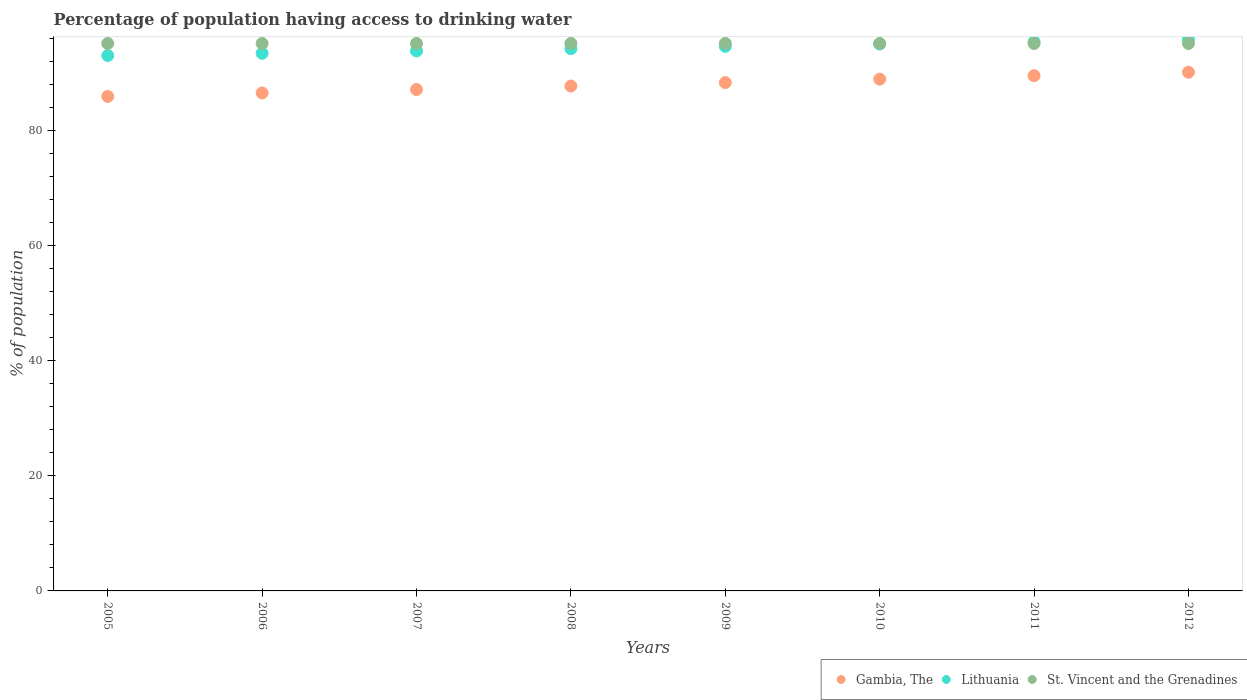Is the number of dotlines equal to the number of legend labels?
Make the answer very short. Yes. What is the percentage of population having access to drinking water in Lithuania in 2006?
Your response must be concise. 93.4. Across all years, what is the maximum percentage of population having access to drinking water in Gambia, The?
Your answer should be compact. 90.1. Across all years, what is the minimum percentage of population having access to drinking water in St. Vincent and the Grenadines?
Your answer should be very brief. 95.1. In which year was the percentage of population having access to drinking water in Gambia, The maximum?
Provide a short and direct response. 2012. What is the total percentage of population having access to drinking water in St. Vincent and the Grenadines in the graph?
Keep it short and to the point. 760.8. What is the difference between the percentage of population having access to drinking water in St. Vincent and the Grenadines in 2010 and that in 2011?
Give a very brief answer. 0. What is the difference between the percentage of population having access to drinking water in Gambia, The in 2012 and the percentage of population having access to drinking water in Lithuania in 2007?
Your answer should be very brief. -3.7. What is the average percentage of population having access to drinking water in Lithuania per year?
Keep it short and to the point. 94.4. In the year 2012, what is the difference between the percentage of population having access to drinking water in Lithuania and percentage of population having access to drinking water in Gambia, The?
Give a very brief answer. 5.7. In how many years, is the percentage of population having access to drinking water in St. Vincent and the Grenadines greater than 44 %?
Keep it short and to the point. 8. What is the ratio of the percentage of population having access to drinking water in Gambia, The in 2007 to that in 2009?
Offer a terse response. 0.99. What is the difference between the highest and the second highest percentage of population having access to drinking water in Lithuania?
Offer a very short reply. 0.4. What is the difference between the highest and the lowest percentage of population having access to drinking water in Lithuania?
Keep it short and to the point. 2.8. Is the percentage of population having access to drinking water in Lithuania strictly greater than the percentage of population having access to drinking water in St. Vincent and the Grenadines over the years?
Your response must be concise. No. Is the percentage of population having access to drinking water in Lithuania strictly less than the percentage of population having access to drinking water in Gambia, The over the years?
Give a very brief answer. No. Are the values on the major ticks of Y-axis written in scientific E-notation?
Make the answer very short. No. Does the graph contain any zero values?
Ensure brevity in your answer.  No. Does the graph contain grids?
Keep it short and to the point. No. How many legend labels are there?
Provide a short and direct response. 3. How are the legend labels stacked?
Ensure brevity in your answer.  Horizontal. What is the title of the graph?
Offer a terse response. Percentage of population having access to drinking water. What is the label or title of the Y-axis?
Provide a succinct answer. % of population. What is the % of population in Gambia, The in 2005?
Keep it short and to the point. 85.9. What is the % of population of Lithuania in 2005?
Your response must be concise. 93. What is the % of population of St. Vincent and the Grenadines in 2005?
Make the answer very short. 95.1. What is the % of population of Gambia, The in 2006?
Make the answer very short. 86.5. What is the % of population of Lithuania in 2006?
Offer a very short reply. 93.4. What is the % of population of St. Vincent and the Grenadines in 2006?
Provide a short and direct response. 95.1. What is the % of population in Gambia, The in 2007?
Your answer should be compact. 87.1. What is the % of population in Lithuania in 2007?
Keep it short and to the point. 93.8. What is the % of population in St. Vincent and the Grenadines in 2007?
Your response must be concise. 95.1. What is the % of population in Gambia, The in 2008?
Offer a very short reply. 87.7. What is the % of population in Lithuania in 2008?
Your response must be concise. 94.2. What is the % of population of St. Vincent and the Grenadines in 2008?
Keep it short and to the point. 95.1. What is the % of population in Gambia, The in 2009?
Your answer should be very brief. 88.3. What is the % of population of Lithuania in 2009?
Offer a very short reply. 94.6. What is the % of population of St. Vincent and the Grenadines in 2009?
Offer a very short reply. 95.1. What is the % of population of Gambia, The in 2010?
Make the answer very short. 88.9. What is the % of population of Lithuania in 2010?
Offer a very short reply. 95. What is the % of population in St. Vincent and the Grenadines in 2010?
Ensure brevity in your answer.  95.1. What is the % of population of Gambia, The in 2011?
Offer a terse response. 89.5. What is the % of population of Lithuania in 2011?
Provide a succinct answer. 95.4. What is the % of population in St. Vincent and the Grenadines in 2011?
Ensure brevity in your answer.  95.1. What is the % of population in Gambia, The in 2012?
Offer a terse response. 90.1. What is the % of population in Lithuania in 2012?
Offer a very short reply. 95.8. What is the % of population in St. Vincent and the Grenadines in 2012?
Your answer should be compact. 95.1. Across all years, what is the maximum % of population in Gambia, The?
Your answer should be very brief. 90.1. Across all years, what is the maximum % of population in Lithuania?
Provide a succinct answer. 95.8. Across all years, what is the maximum % of population in St. Vincent and the Grenadines?
Make the answer very short. 95.1. Across all years, what is the minimum % of population of Gambia, The?
Keep it short and to the point. 85.9. Across all years, what is the minimum % of population in Lithuania?
Make the answer very short. 93. Across all years, what is the minimum % of population of St. Vincent and the Grenadines?
Your answer should be compact. 95.1. What is the total % of population in Gambia, The in the graph?
Provide a short and direct response. 704. What is the total % of population in Lithuania in the graph?
Your response must be concise. 755.2. What is the total % of population of St. Vincent and the Grenadines in the graph?
Make the answer very short. 760.8. What is the difference between the % of population in Gambia, The in 2005 and that in 2006?
Give a very brief answer. -0.6. What is the difference between the % of population in Lithuania in 2005 and that in 2006?
Your response must be concise. -0.4. What is the difference between the % of population of Gambia, The in 2005 and that in 2007?
Make the answer very short. -1.2. What is the difference between the % of population in Lithuania in 2005 and that in 2007?
Keep it short and to the point. -0.8. What is the difference between the % of population of St. Vincent and the Grenadines in 2005 and that in 2007?
Give a very brief answer. 0. What is the difference between the % of population in Gambia, The in 2005 and that in 2008?
Provide a succinct answer. -1.8. What is the difference between the % of population in Lithuania in 2005 and that in 2008?
Your answer should be very brief. -1.2. What is the difference between the % of population in St. Vincent and the Grenadines in 2005 and that in 2008?
Ensure brevity in your answer.  0. What is the difference between the % of population of Lithuania in 2005 and that in 2009?
Your answer should be compact. -1.6. What is the difference between the % of population of Gambia, The in 2005 and that in 2010?
Your answer should be very brief. -3. What is the difference between the % of population of St. Vincent and the Grenadines in 2005 and that in 2010?
Give a very brief answer. 0. What is the difference between the % of population in St. Vincent and the Grenadines in 2005 and that in 2011?
Your response must be concise. 0. What is the difference between the % of population of Gambia, The in 2005 and that in 2012?
Your response must be concise. -4.2. What is the difference between the % of population of Lithuania in 2005 and that in 2012?
Give a very brief answer. -2.8. What is the difference between the % of population in St. Vincent and the Grenadines in 2005 and that in 2012?
Keep it short and to the point. 0. What is the difference between the % of population in Lithuania in 2006 and that in 2007?
Provide a succinct answer. -0.4. What is the difference between the % of population in St. Vincent and the Grenadines in 2006 and that in 2007?
Make the answer very short. 0. What is the difference between the % of population in Gambia, The in 2006 and that in 2008?
Provide a short and direct response. -1.2. What is the difference between the % of population of Lithuania in 2006 and that in 2008?
Your answer should be compact. -0.8. What is the difference between the % of population of St. Vincent and the Grenadines in 2006 and that in 2008?
Your answer should be compact. 0. What is the difference between the % of population in Gambia, The in 2006 and that in 2009?
Your response must be concise. -1.8. What is the difference between the % of population in Lithuania in 2006 and that in 2009?
Your response must be concise. -1.2. What is the difference between the % of population in Gambia, The in 2006 and that in 2011?
Provide a short and direct response. -3. What is the difference between the % of population of Lithuania in 2006 and that in 2011?
Provide a short and direct response. -2. What is the difference between the % of population in Lithuania in 2006 and that in 2012?
Your answer should be very brief. -2.4. What is the difference between the % of population of St. Vincent and the Grenadines in 2006 and that in 2012?
Give a very brief answer. 0. What is the difference between the % of population in Lithuania in 2007 and that in 2008?
Give a very brief answer. -0.4. What is the difference between the % of population in St. Vincent and the Grenadines in 2007 and that in 2008?
Make the answer very short. 0. What is the difference between the % of population in Gambia, The in 2007 and that in 2009?
Your answer should be very brief. -1.2. What is the difference between the % of population in Lithuania in 2007 and that in 2009?
Offer a very short reply. -0.8. What is the difference between the % of population in St. Vincent and the Grenadines in 2007 and that in 2009?
Give a very brief answer. 0. What is the difference between the % of population of St. Vincent and the Grenadines in 2007 and that in 2010?
Make the answer very short. 0. What is the difference between the % of population in Gambia, The in 2007 and that in 2011?
Keep it short and to the point. -2.4. What is the difference between the % of population in Lithuania in 2007 and that in 2011?
Keep it short and to the point. -1.6. What is the difference between the % of population in St. Vincent and the Grenadines in 2007 and that in 2011?
Make the answer very short. 0. What is the difference between the % of population in Gambia, The in 2008 and that in 2009?
Provide a succinct answer. -0.6. What is the difference between the % of population in Gambia, The in 2008 and that in 2010?
Provide a succinct answer. -1.2. What is the difference between the % of population of Gambia, The in 2008 and that in 2011?
Provide a short and direct response. -1.8. What is the difference between the % of population of Lithuania in 2008 and that in 2012?
Your answer should be compact. -1.6. What is the difference between the % of population in St. Vincent and the Grenadines in 2008 and that in 2012?
Provide a succinct answer. 0. What is the difference between the % of population in Lithuania in 2009 and that in 2010?
Offer a very short reply. -0.4. What is the difference between the % of population in St. Vincent and the Grenadines in 2009 and that in 2011?
Ensure brevity in your answer.  0. What is the difference between the % of population of Gambia, The in 2009 and that in 2012?
Keep it short and to the point. -1.8. What is the difference between the % of population of Gambia, The in 2010 and that in 2011?
Give a very brief answer. -0.6. What is the difference between the % of population of Lithuania in 2010 and that in 2011?
Keep it short and to the point. -0.4. What is the difference between the % of population of St. Vincent and the Grenadines in 2010 and that in 2011?
Offer a terse response. 0. What is the difference between the % of population of Lithuania in 2010 and that in 2012?
Provide a short and direct response. -0.8. What is the difference between the % of population in Gambia, The in 2011 and that in 2012?
Provide a succinct answer. -0.6. What is the difference between the % of population in Lithuania in 2011 and that in 2012?
Make the answer very short. -0.4. What is the difference between the % of population of Gambia, The in 2005 and the % of population of St. Vincent and the Grenadines in 2006?
Ensure brevity in your answer.  -9.2. What is the difference between the % of population in Lithuania in 2005 and the % of population in St. Vincent and the Grenadines in 2006?
Give a very brief answer. -2.1. What is the difference between the % of population of Gambia, The in 2005 and the % of population of St. Vincent and the Grenadines in 2007?
Your response must be concise. -9.2. What is the difference between the % of population in Lithuania in 2005 and the % of population in St. Vincent and the Grenadines in 2007?
Your response must be concise. -2.1. What is the difference between the % of population in Gambia, The in 2005 and the % of population in Lithuania in 2008?
Make the answer very short. -8.3. What is the difference between the % of population in Gambia, The in 2005 and the % of population in Lithuania in 2009?
Provide a succinct answer. -8.7. What is the difference between the % of population of Gambia, The in 2005 and the % of population of St. Vincent and the Grenadines in 2009?
Give a very brief answer. -9.2. What is the difference between the % of population in Gambia, The in 2005 and the % of population in Lithuania in 2010?
Your answer should be very brief. -9.1. What is the difference between the % of population in Lithuania in 2005 and the % of population in St. Vincent and the Grenadines in 2010?
Provide a succinct answer. -2.1. What is the difference between the % of population of Gambia, The in 2005 and the % of population of St. Vincent and the Grenadines in 2011?
Make the answer very short. -9.2. What is the difference between the % of population in Gambia, The in 2005 and the % of population in Lithuania in 2012?
Provide a succinct answer. -9.9. What is the difference between the % of population of Lithuania in 2005 and the % of population of St. Vincent and the Grenadines in 2012?
Ensure brevity in your answer.  -2.1. What is the difference between the % of population of Gambia, The in 2006 and the % of population of Lithuania in 2007?
Your response must be concise. -7.3. What is the difference between the % of population of Gambia, The in 2006 and the % of population of St. Vincent and the Grenadines in 2007?
Give a very brief answer. -8.6. What is the difference between the % of population in Lithuania in 2006 and the % of population in St. Vincent and the Grenadines in 2007?
Provide a succinct answer. -1.7. What is the difference between the % of population of Gambia, The in 2006 and the % of population of St. Vincent and the Grenadines in 2008?
Make the answer very short. -8.6. What is the difference between the % of population of Gambia, The in 2006 and the % of population of St. Vincent and the Grenadines in 2009?
Offer a very short reply. -8.6. What is the difference between the % of population in Lithuania in 2006 and the % of population in St. Vincent and the Grenadines in 2010?
Offer a very short reply. -1.7. What is the difference between the % of population in Gambia, The in 2006 and the % of population in St. Vincent and the Grenadines in 2011?
Make the answer very short. -8.6. What is the difference between the % of population in Gambia, The in 2006 and the % of population in St. Vincent and the Grenadines in 2012?
Your answer should be compact. -8.6. What is the difference between the % of population in Gambia, The in 2007 and the % of population in St. Vincent and the Grenadines in 2008?
Your answer should be very brief. -8. What is the difference between the % of population in Lithuania in 2007 and the % of population in St. Vincent and the Grenadines in 2008?
Offer a terse response. -1.3. What is the difference between the % of population in Gambia, The in 2007 and the % of population in Lithuania in 2009?
Make the answer very short. -7.5. What is the difference between the % of population of Gambia, The in 2007 and the % of population of St. Vincent and the Grenadines in 2009?
Provide a short and direct response. -8. What is the difference between the % of population in Lithuania in 2007 and the % of population in St. Vincent and the Grenadines in 2009?
Your response must be concise. -1.3. What is the difference between the % of population in Gambia, The in 2007 and the % of population in St. Vincent and the Grenadines in 2010?
Offer a very short reply. -8. What is the difference between the % of population of Lithuania in 2007 and the % of population of St. Vincent and the Grenadines in 2010?
Keep it short and to the point. -1.3. What is the difference between the % of population of Gambia, The in 2007 and the % of population of St. Vincent and the Grenadines in 2011?
Make the answer very short. -8. What is the difference between the % of population of Lithuania in 2007 and the % of population of St. Vincent and the Grenadines in 2011?
Provide a succinct answer. -1.3. What is the difference between the % of population of Gambia, The in 2007 and the % of population of Lithuania in 2012?
Keep it short and to the point. -8.7. What is the difference between the % of population of Gambia, The in 2007 and the % of population of St. Vincent and the Grenadines in 2012?
Offer a terse response. -8. What is the difference between the % of population in Gambia, The in 2008 and the % of population in St. Vincent and the Grenadines in 2009?
Provide a short and direct response. -7.4. What is the difference between the % of population of Gambia, The in 2008 and the % of population of Lithuania in 2010?
Provide a succinct answer. -7.3. What is the difference between the % of population in Lithuania in 2008 and the % of population in St. Vincent and the Grenadines in 2010?
Keep it short and to the point. -0.9. What is the difference between the % of population in Gambia, The in 2008 and the % of population in Lithuania in 2011?
Provide a short and direct response. -7.7. What is the difference between the % of population of Lithuania in 2008 and the % of population of St. Vincent and the Grenadines in 2012?
Make the answer very short. -0.9. What is the difference between the % of population in Gambia, The in 2009 and the % of population in St. Vincent and the Grenadines in 2010?
Ensure brevity in your answer.  -6.8. What is the difference between the % of population in Gambia, The in 2009 and the % of population in Lithuania in 2011?
Provide a succinct answer. -7.1. What is the difference between the % of population of Lithuania in 2009 and the % of population of St. Vincent and the Grenadines in 2012?
Offer a terse response. -0.5. What is the difference between the % of population in Gambia, The in 2010 and the % of population in Lithuania in 2011?
Give a very brief answer. -6.5. What is the difference between the % of population in Gambia, The in 2010 and the % of population in St. Vincent and the Grenadines in 2011?
Offer a terse response. -6.2. What is the difference between the % of population of Gambia, The in 2010 and the % of population of St. Vincent and the Grenadines in 2012?
Offer a terse response. -6.2. What is the difference between the % of population of Gambia, The in 2011 and the % of population of Lithuania in 2012?
Ensure brevity in your answer.  -6.3. What is the difference between the % of population in Gambia, The in 2011 and the % of population in St. Vincent and the Grenadines in 2012?
Give a very brief answer. -5.6. What is the difference between the % of population of Lithuania in 2011 and the % of population of St. Vincent and the Grenadines in 2012?
Give a very brief answer. 0.3. What is the average % of population in Lithuania per year?
Offer a terse response. 94.4. What is the average % of population in St. Vincent and the Grenadines per year?
Offer a very short reply. 95.1. In the year 2005, what is the difference between the % of population of Gambia, The and % of population of Lithuania?
Keep it short and to the point. -7.1. In the year 2005, what is the difference between the % of population of Gambia, The and % of population of St. Vincent and the Grenadines?
Your response must be concise. -9.2. In the year 2005, what is the difference between the % of population of Lithuania and % of population of St. Vincent and the Grenadines?
Ensure brevity in your answer.  -2.1. In the year 2006, what is the difference between the % of population in Gambia, The and % of population in Lithuania?
Offer a terse response. -6.9. In the year 2007, what is the difference between the % of population in Lithuania and % of population in St. Vincent and the Grenadines?
Your answer should be compact. -1.3. In the year 2008, what is the difference between the % of population of Gambia, The and % of population of Lithuania?
Offer a very short reply. -6.5. In the year 2008, what is the difference between the % of population of Gambia, The and % of population of St. Vincent and the Grenadines?
Provide a short and direct response. -7.4. In the year 2008, what is the difference between the % of population of Lithuania and % of population of St. Vincent and the Grenadines?
Your response must be concise. -0.9. In the year 2010, what is the difference between the % of population of Gambia, The and % of population of Lithuania?
Provide a succinct answer. -6.1. In the year 2011, what is the difference between the % of population in Gambia, The and % of population in Lithuania?
Your answer should be very brief. -5.9. In the year 2011, what is the difference between the % of population of Lithuania and % of population of St. Vincent and the Grenadines?
Your answer should be compact. 0.3. In the year 2012, what is the difference between the % of population of Gambia, The and % of population of Lithuania?
Provide a succinct answer. -5.7. In the year 2012, what is the difference between the % of population of Gambia, The and % of population of St. Vincent and the Grenadines?
Give a very brief answer. -5. What is the ratio of the % of population of St. Vincent and the Grenadines in 2005 to that in 2006?
Give a very brief answer. 1. What is the ratio of the % of population in Gambia, The in 2005 to that in 2007?
Give a very brief answer. 0.99. What is the ratio of the % of population of Lithuania in 2005 to that in 2007?
Provide a short and direct response. 0.99. What is the ratio of the % of population of Gambia, The in 2005 to that in 2008?
Ensure brevity in your answer.  0.98. What is the ratio of the % of population in Lithuania in 2005 to that in 2008?
Offer a very short reply. 0.99. What is the ratio of the % of population of St. Vincent and the Grenadines in 2005 to that in 2008?
Keep it short and to the point. 1. What is the ratio of the % of population in Gambia, The in 2005 to that in 2009?
Offer a terse response. 0.97. What is the ratio of the % of population of Lithuania in 2005 to that in 2009?
Give a very brief answer. 0.98. What is the ratio of the % of population of St. Vincent and the Grenadines in 2005 to that in 2009?
Make the answer very short. 1. What is the ratio of the % of population of Gambia, The in 2005 to that in 2010?
Your response must be concise. 0.97. What is the ratio of the % of population of Lithuania in 2005 to that in 2010?
Offer a very short reply. 0.98. What is the ratio of the % of population in St. Vincent and the Grenadines in 2005 to that in 2010?
Your response must be concise. 1. What is the ratio of the % of population of Gambia, The in 2005 to that in 2011?
Ensure brevity in your answer.  0.96. What is the ratio of the % of population of Lithuania in 2005 to that in 2011?
Make the answer very short. 0.97. What is the ratio of the % of population of St. Vincent and the Grenadines in 2005 to that in 2011?
Your answer should be very brief. 1. What is the ratio of the % of population in Gambia, The in 2005 to that in 2012?
Offer a terse response. 0.95. What is the ratio of the % of population in Lithuania in 2005 to that in 2012?
Offer a terse response. 0.97. What is the ratio of the % of population in St. Vincent and the Grenadines in 2005 to that in 2012?
Provide a succinct answer. 1. What is the ratio of the % of population of Lithuania in 2006 to that in 2007?
Your response must be concise. 1. What is the ratio of the % of population of Gambia, The in 2006 to that in 2008?
Keep it short and to the point. 0.99. What is the ratio of the % of population in Lithuania in 2006 to that in 2008?
Make the answer very short. 0.99. What is the ratio of the % of population of St. Vincent and the Grenadines in 2006 to that in 2008?
Keep it short and to the point. 1. What is the ratio of the % of population in Gambia, The in 2006 to that in 2009?
Your answer should be very brief. 0.98. What is the ratio of the % of population in Lithuania in 2006 to that in 2009?
Give a very brief answer. 0.99. What is the ratio of the % of population in St. Vincent and the Grenadines in 2006 to that in 2009?
Your answer should be very brief. 1. What is the ratio of the % of population in Gambia, The in 2006 to that in 2010?
Offer a terse response. 0.97. What is the ratio of the % of population in Lithuania in 2006 to that in 2010?
Your answer should be very brief. 0.98. What is the ratio of the % of population in St. Vincent and the Grenadines in 2006 to that in 2010?
Provide a succinct answer. 1. What is the ratio of the % of population in Gambia, The in 2006 to that in 2011?
Your answer should be compact. 0.97. What is the ratio of the % of population in Lithuania in 2006 to that in 2011?
Provide a succinct answer. 0.98. What is the ratio of the % of population of Lithuania in 2006 to that in 2012?
Give a very brief answer. 0.97. What is the ratio of the % of population in St. Vincent and the Grenadines in 2006 to that in 2012?
Your response must be concise. 1. What is the ratio of the % of population in Gambia, The in 2007 to that in 2008?
Offer a very short reply. 0.99. What is the ratio of the % of population of Lithuania in 2007 to that in 2008?
Provide a succinct answer. 1. What is the ratio of the % of population of St. Vincent and the Grenadines in 2007 to that in 2008?
Ensure brevity in your answer.  1. What is the ratio of the % of population in Gambia, The in 2007 to that in 2009?
Offer a very short reply. 0.99. What is the ratio of the % of population of Lithuania in 2007 to that in 2009?
Ensure brevity in your answer.  0.99. What is the ratio of the % of population of Gambia, The in 2007 to that in 2010?
Ensure brevity in your answer.  0.98. What is the ratio of the % of population in Lithuania in 2007 to that in 2010?
Your answer should be compact. 0.99. What is the ratio of the % of population in Gambia, The in 2007 to that in 2011?
Make the answer very short. 0.97. What is the ratio of the % of population in Lithuania in 2007 to that in 2011?
Ensure brevity in your answer.  0.98. What is the ratio of the % of population of St. Vincent and the Grenadines in 2007 to that in 2011?
Keep it short and to the point. 1. What is the ratio of the % of population in Gambia, The in 2007 to that in 2012?
Your response must be concise. 0.97. What is the ratio of the % of population in Lithuania in 2007 to that in 2012?
Keep it short and to the point. 0.98. What is the ratio of the % of population in St. Vincent and the Grenadines in 2007 to that in 2012?
Provide a succinct answer. 1. What is the ratio of the % of population of St. Vincent and the Grenadines in 2008 to that in 2009?
Provide a succinct answer. 1. What is the ratio of the % of population in Gambia, The in 2008 to that in 2010?
Your answer should be compact. 0.99. What is the ratio of the % of population in Lithuania in 2008 to that in 2010?
Your answer should be very brief. 0.99. What is the ratio of the % of population of St. Vincent and the Grenadines in 2008 to that in 2010?
Give a very brief answer. 1. What is the ratio of the % of population of Gambia, The in 2008 to that in 2011?
Provide a succinct answer. 0.98. What is the ratio of the % of population in Lithuania in 2008 to that in 2011?
Your answer should be compact. 0.99. What is the ratio of the % of population of St. Vincent and the Grenadines in 2008 to that in 2011?
Give a very brief answer. 1. What is the ratio of the % of population of Gambia, The in 2008 to that in 2012?
Make the answer very short. 0.97. What is the ratio of the % of population of Lithuania in 2008 to that in 2012?
Provide a short and direct response. 0.98. What is the ratio of the % of population in St. Vincent and the Grenadines in 2008 to that in 2012?
Offer a very short reply. 1. What is the ratio of the % of population in Gambia, The in 2009 to that in 2011?
Provide a succinct answer. 0.99. What is the ratio of the % of population in Gambia, The in 2009 to that in 2012?
Give a very brief answer. 0.98. What is the ratio of the % of population in Lithuania in 2009 to that in 2012?
Offer a very short reply. 0.99. What is the ratio of the % of population of St. Vincent and the Grenadines in 2009 to that in 2012?
Offer a very short reply. 1. What is the ratio of the % of population of Gambia, The in 2010 to that in 2012?
Give a very brief answer. 0.99. What is the ratio of the % of population of Lithuania in 2010 to that in 2012?
Your answer should be compact. 0.99. What is the ratio of the % of population in Gambia, The in 2011 to that in 2012?
Your answer should be compact. 0.99. What is the ratio of the % of population in Lithuania in 2011 to that in 2012?
Ensure brevity in your answer.  1. What is the ratio of the % of population of St. Vincent and the Grenadines in 2011 to that in 2012?
Make the answer very short. 1. What is the difference between the highest and the second highest % of population in Lithuania?
Offer a terse response. 0.4. What is the difference between the highest and the second highest % of population in St. Vincent and the Grenadines?
Your answer should be very brief. 0. What is the difference between the highest and the lowest % of population in Lithuania?
Offer a terse response. 2.8. What is the difference between the highest and the lowest % of population of St. Vincent and the Grenadines?
Offer a very short reply. 0. 